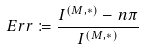<formula> <loc_0><loc_0><loc_500><loc_500>E r r \coloneqq \frac { I ^ { ( M , \ast ) } - n \pi } { I ^ { ( M , \ast ) } }</formula> 